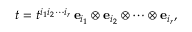Convert formula to latex. <formula><loc_0><loc_0><loc_500><loc_500>t = t ^ { i _ { 1 } i _ { 2 } \cdots i _ { r } } \, { e } _ { i _ { 1 } } \otimes { e } _ { i _ { 2 } } \otimes \cdots \otimes { e } _ { i _ { r } } ,</formula> 